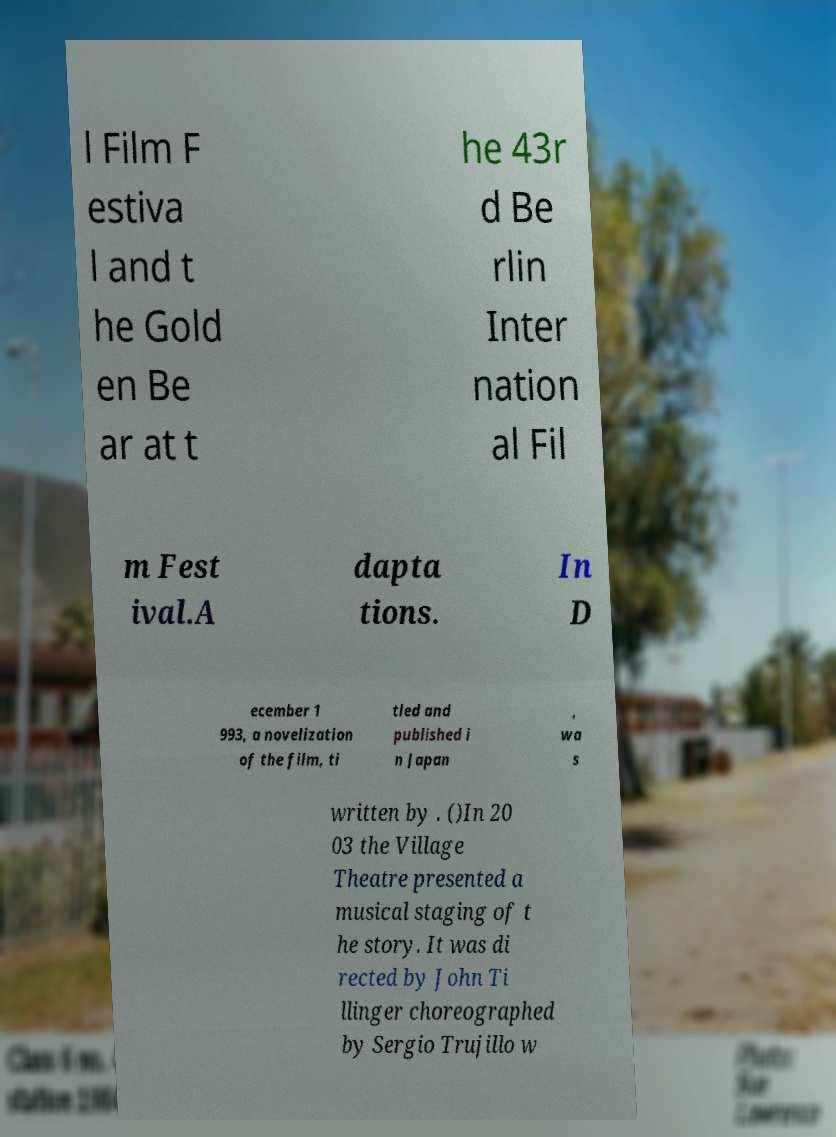I need the written content from this picture converted into text. Can you do that? l Film F estiva l and t he Gold en Be ar at t he 43r d Be rlin Inter nation al Fil m Fest ival.A dapta tions. In D ecember 1 993, a novelization of the film, ti tled and published i n Japan , wa s written by . ()In 20 03 the Village Theatre presented a musical staging of t he story. It was di rected by John Ti llinger choreographed by Sergio Trujillo w 